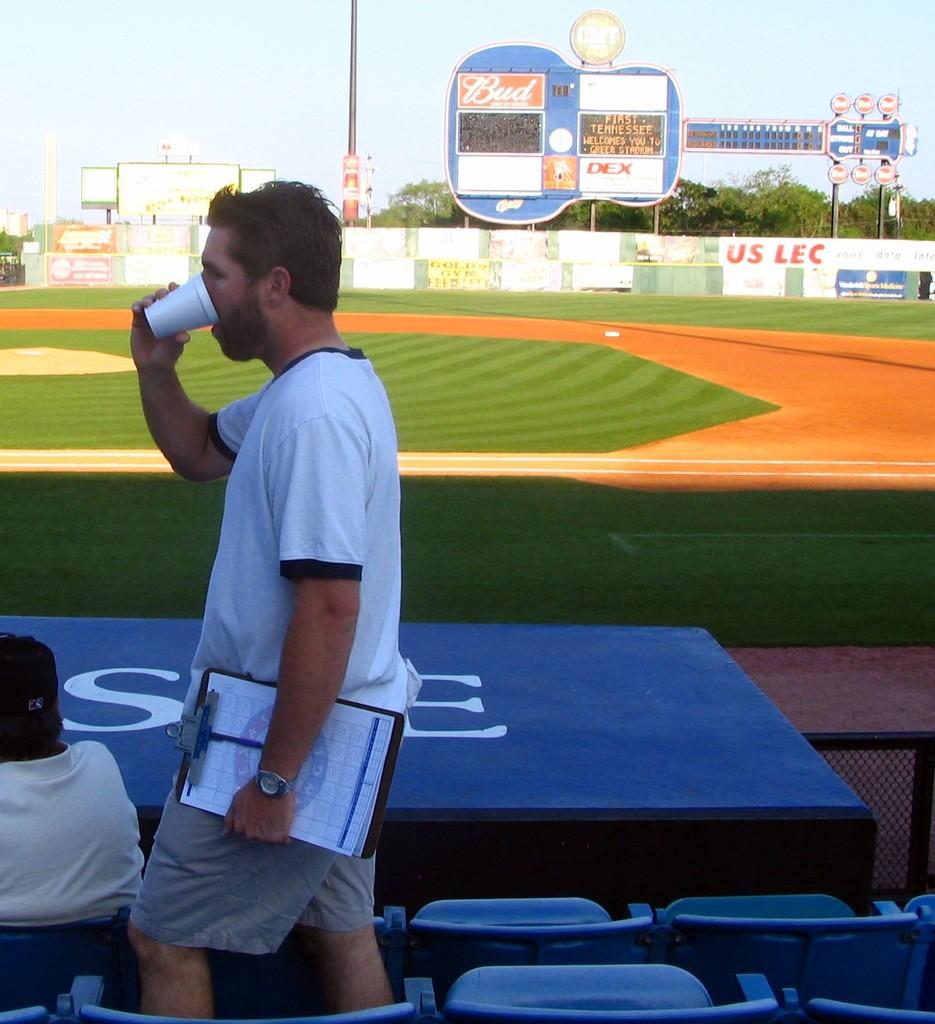What do the red letters in the back on the left say?
Your answer should be compact. Us lec. 